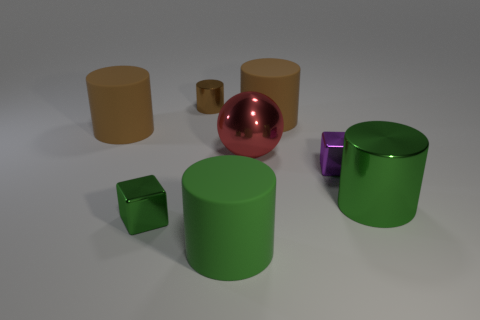What is the color of the tiny shiny cylinder?
Offer a very short reply. Brown. What number of tiny things are either red balls or brown matte things?
Provide a short and direct response. 0. Does the cylinder that is on the left side of the tiny brown thing have the same size as the metal cylinder on the left side of the green matte cylinder?
Your answer should be very brief. No. What is the size of the other metallic thing that is the same shape as the large green shiny object?
Your answer should be compact. Small. Is the number of tiny brown shiny things that are behind the tiny purple cube greater than the number of large brown rubber cylinders right of the tiny metallic cylinder?
Offer a terse response. No. There is a cylinder that is both in front of the purple metallic cube and to the right of the green rubber thing; what is its material?
Your response must be concise. Metal. There is another tiny metallic object that is the same shape as the small purple metal object; what is its color?
Provide a short and direct response. Green. The purple shiny block has what size?
Your answer should be compact. Small. There is a large thing in front of the large green object that is on the right side of the big red thing; what is its color?
Give a very brief answer. Green. What number of objects are both in front of the green block and right of the large green matte cylinder?
Ensure brevity in your answer.  0. 